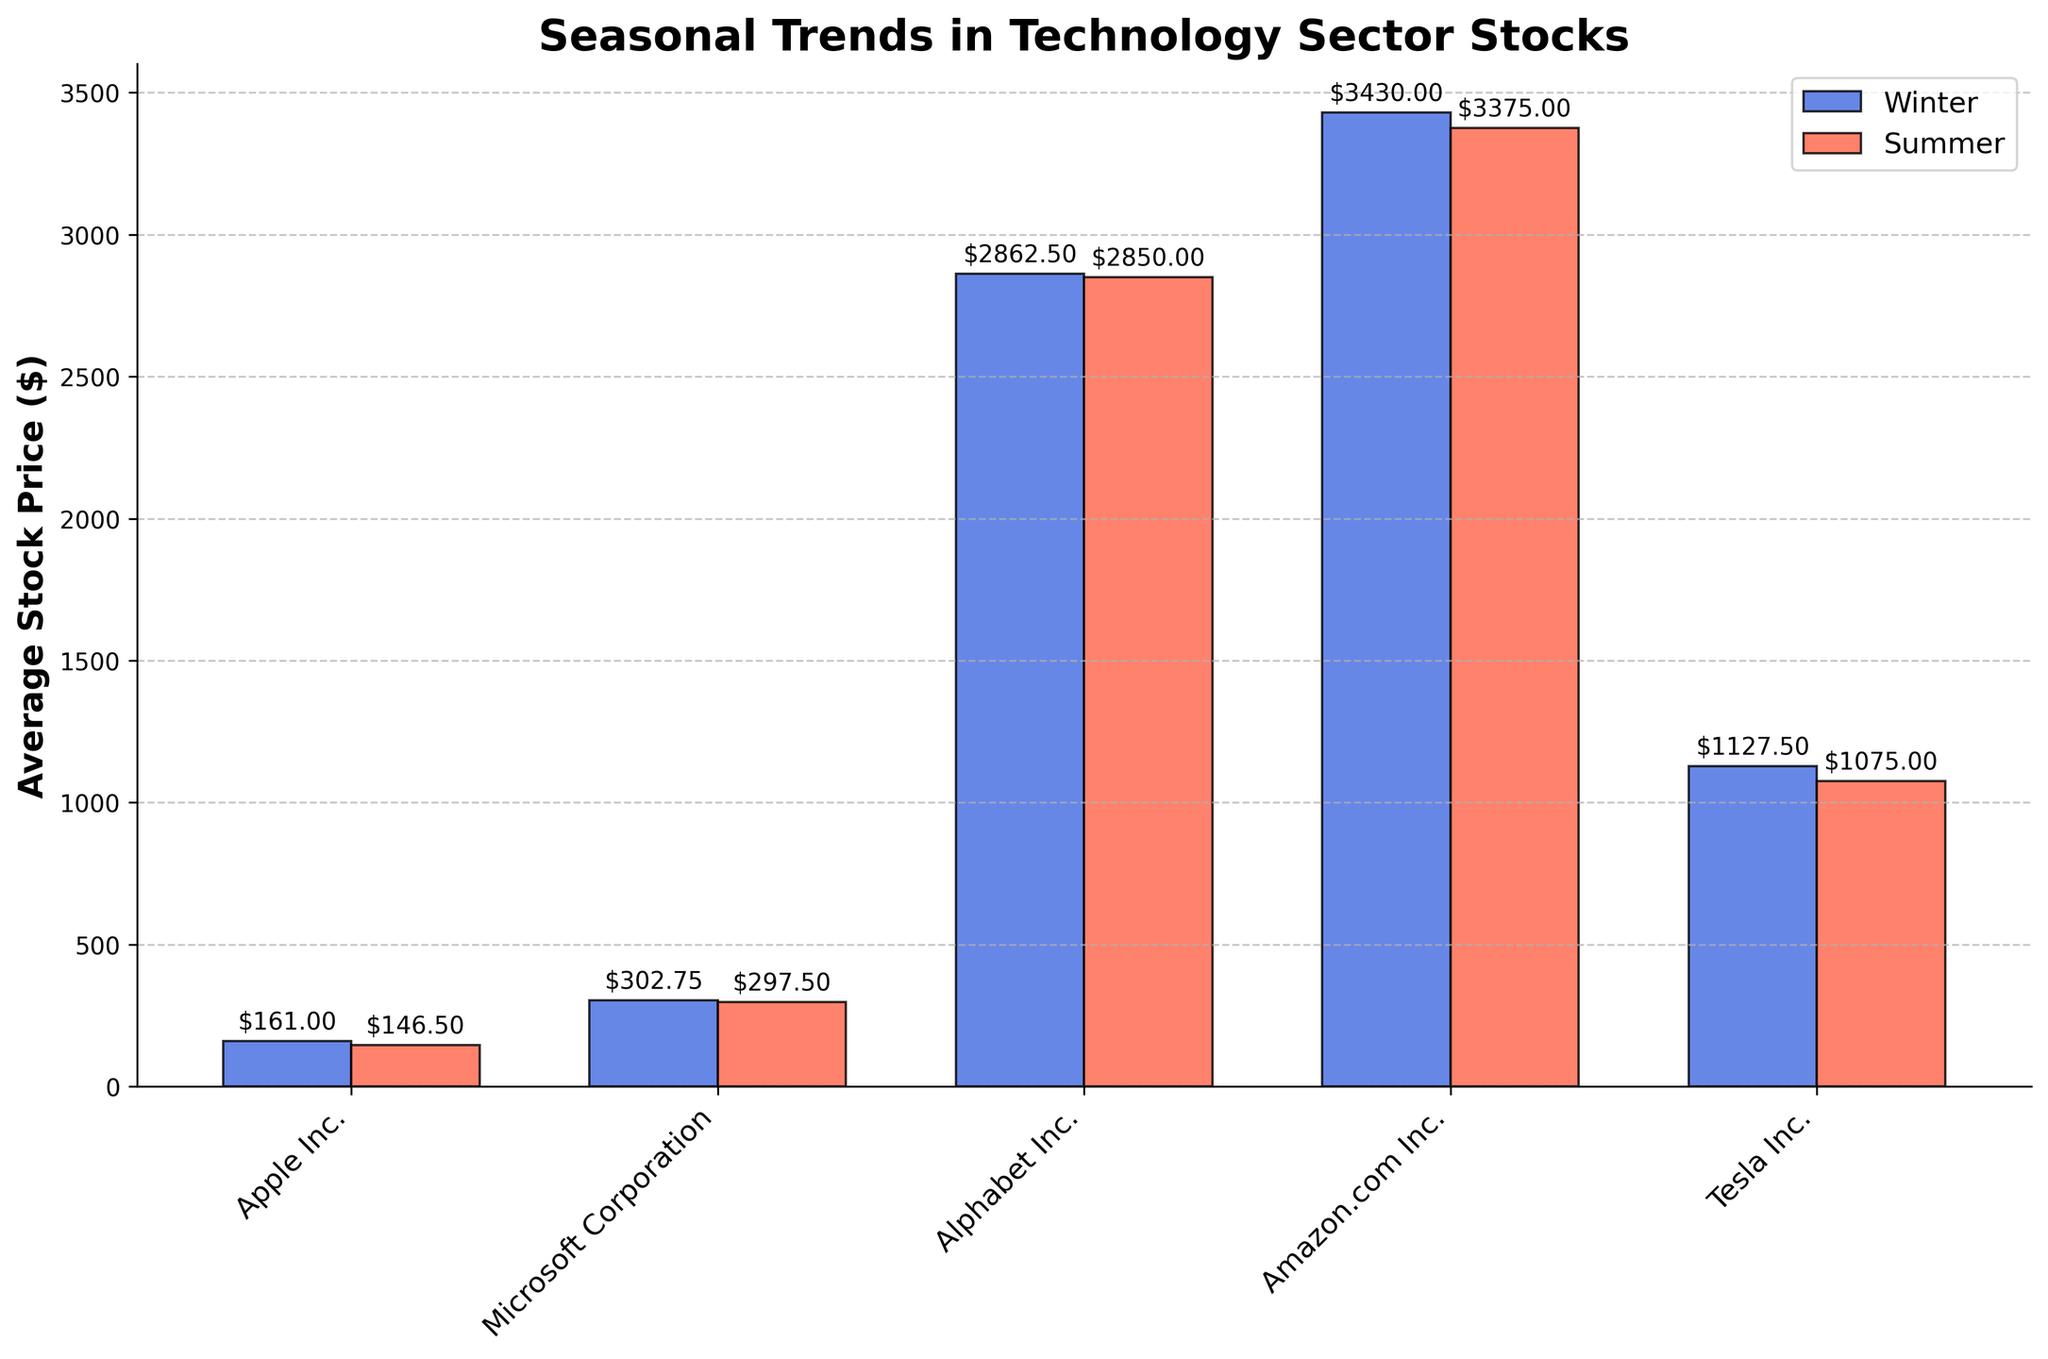What's the title of the plot? The title is prominently displayed at the top of the plot. It's written in a large, bold font to grab attention and convey the main subject of the plot.
Answer: Seasonal Trends in Technology Sector Stocks Which company has the highest average stock price in the Winter season? By observing the blue bars, which represent Winter stock prices, the tallest blue bar corresponds to Amazon.com Inc.
Answer: Amazon.com Inc What is the difference in average stock price for Microsoft Corporation between Winter and Summer? Find the heights of the blue Winter bar and the red Summer bar for Microsoft Corporation. The Winter average is roughly $302.75 and the Summer average is approximately $297.5. The difference is calculated as $302.75 - $297.5.
Answer: $5.25 How do the average stock prices of Tesla Inc. compare between Winter and Summer? Compare the height of the blue bar (Winter) and the red bar (Summer) for Tesla Inc., observing whether the Winter bar is taller, shorter, or equal in height to the Summer bar.
Answer: Winter is higher than Summer Which company shows the least variation in average stock prices between Winter and Summer? Examine the heights of the blue and red bars for each company. The company with the smallest difference in bar heights between the two seasons will have the least variation.
Answer: Microsoft Corporation What is the average stock price for Apple Inc. in Summer? Look at the height of the red bar for Apple Inc., which visually represents the average stock price in Summer.
Answer: Approximately $146.50 How does the average stock price for Alphabet Inc. in Winter compare to that in Summer? Evaluate the heights of the blue bar (Winter) and the red bar (Summer) for Alphabet Inc. Specifically, check if the blue bar is higher, lower, or approximately the same as the red bar.
Answer: Winter is slightly higher than Summer What is the range of average stock prices for all companies in Summer? Identify the highest red bar and the lowest red bar among all companies. The highest red bar represents Amazon.com Inc. ($3375), and the lowest represents Apple Inc. ($146.5). The range is calculated by subtracting the lowest from the highest average stock price.
Answer: Approximately $3228.50 Which season shows generally higher stock prices across most companies? Compare the overall height patterns of blue bars (Winter) and red bars (Summer). Determine whether there are more cases where blue bars are higher or where red bars are higher.
Answer: Winter What is the total difference in average stock prices between Winter and Summer for all companies combined? For each company, subtract the Summer average stock price from the Winter average stock price and then sum these differences across all companies. (For instance, Apple Inc. difference is ~$6.00, Microsoft Corporation ~$5.25, Alphabet Inc. ~$25.00, Amazon.com Inc. ~$50, Tesla Inc. ~$52.50. Summing these values.)
Answer: Approximately $138.75 